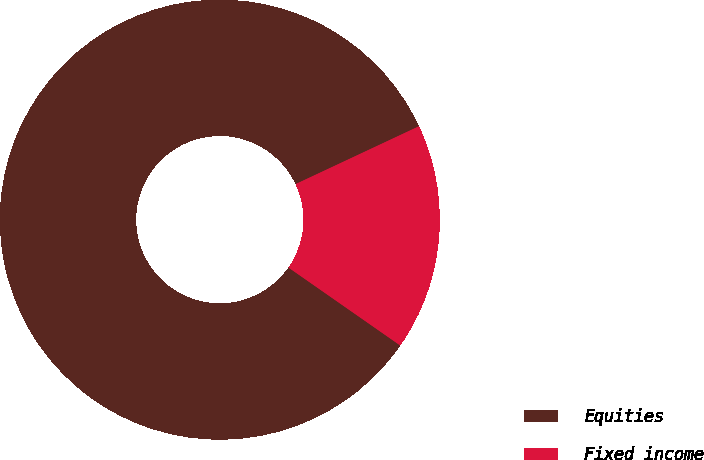<chart> <loc_0><loc_0><loc_500><loc_500><pie_chart><fcel>Equities<fcel>Fixed income<nl><fcel>83.33%<fcel>16.67%<nl></chart> 